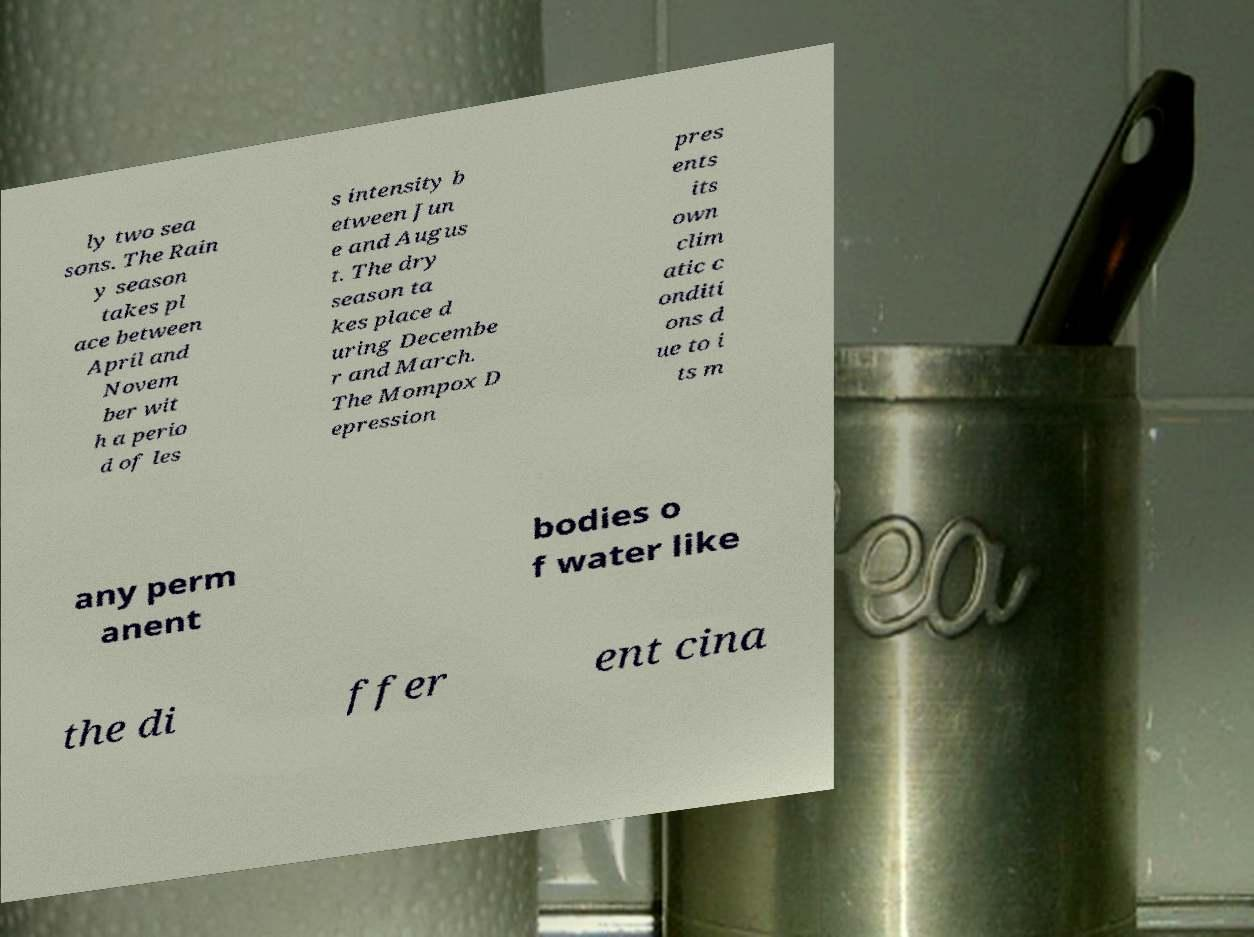Could you assist in decoding the text presented in this image and type it out clearly? ly two sea sons. The Rain y season takes pl ace between April and Novem ber wit h a perio d of les s intensity b etween Jun e and Augus t. The dry season ta kes place d uring Decembe r and March. The Mompox D epression pres ents its own clim atic c onditi ons d ue to i ts m any perm anent bodies o f water like the di ffer ent cina 